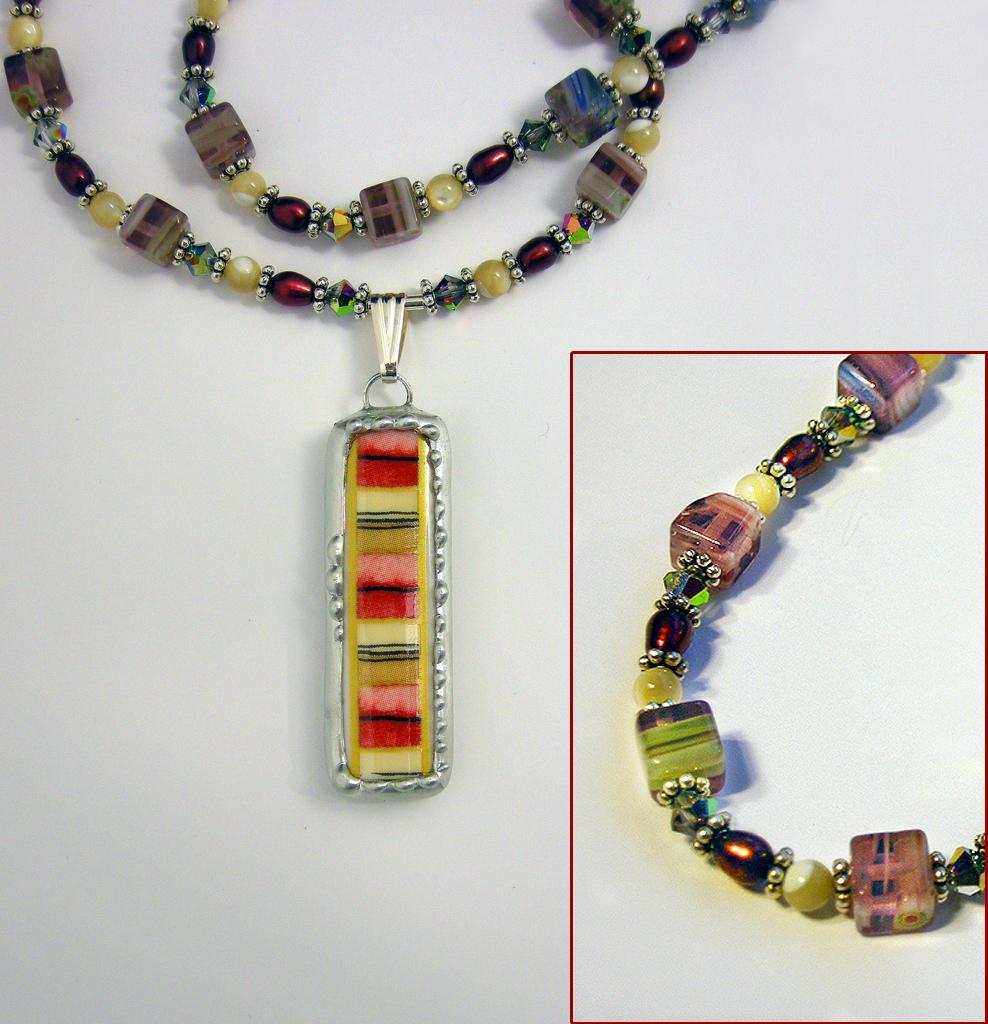Please provide a concise description of this image. In this image there is a chain on the floor. Right side there is an image of a chain having few beads and pearls. Left side chain is having a pendant. 